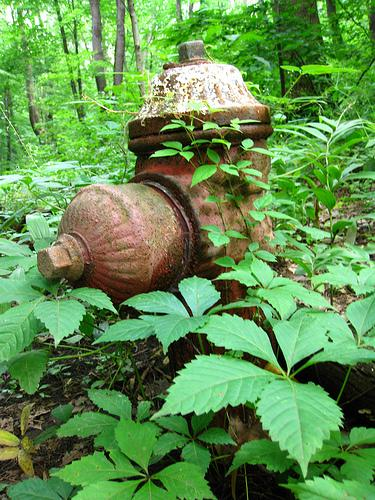What specific object is attached to the fire hydrant? A bolt on the hydrant's cap and a dark grey square on top. Mention the location of the fire hydrant. The fire hydrant is located in the woods. What is the condition of the fire hydrant in the image? The fire hydrant is in a decrepit and worn condition, with chipping white paint and rust. Explain the interaction between the fire hydrant and its surroundings. The fire hydrant is partially hidden and being encroached upon by the surrounding plants and weeds. Identify the primary object in the image and its color. An old fire hydrant is the primary object and it is red and white in color. How many valves are visible on the fire hydrant in the image? One valve is visible on the fire hydrant. Describe the state of the plants around the fire hydrant. The plants are almost covering the hydrant and beginning to hide it. Assess the sentiment evoked by the image, taking into account the fire hydrant's condition and surroundings. The sentiment evoked is a sense of neglect and abandonment, as the old and worn fire hydrant is being overtaken by nature in the woods. What features make the fire hydrant unique in this image? The fire hydrant's old and worn appearance, white chipping paint, rust, and green moss make it unique. Enumerate the vegetation elements surrounding the fire hydrant. Plants, trees, dead leaves, weeds, and moss are surrounding the fire hydrant. Is there a purple flower next to the fire hydrant? There is no mention of a purple flower or any specific color of flower in the given image information. The objects mentioned are mainly related to the fire hydrant, trees, and plants but without any specific color attribute for flowers. What attributes can be noticed on the fire hydrant in the woods? Rusted, mossy, chipping paint, one valve, bolt on the cap How are the plants and fire hydrant interacting in this image? Plants are growing around and almost covering the hydrant. What type of vegetation is present near the fire hydrant? Plants, trees, grass, and weeds. Can you find a cat near the fire hydrant? There is no mention of a cat or any animals in the given image information. The objects mentioned in the image are mostly related to the fire hydrant, trees, and plants. What is the overall atmosphere of the image? Is it positive or negative? Negative, due to the old and decrepit state of the hydrant. Can you find a tall building behind the fire hydrant? There is no mention of a tall building or any buildings in the given image information. The scene in the image is described as a fire hydrant in the woods or forest, with no mention of any urban elements like buildings. How many total valves are found on the fire hydrant? One valve. Is there a person standing next to the fire hydrant? There is no mention of a person or any human figure in the given image information. The objects mentioned in the image are all inanimate objects such as the fire hydrant, plants, and trees. Identify the segments covered by plants in the image. X:30 Y:108 Width:339 Height:339 Identify any unusual elements in the image. Fire hydrant in the woods surrounded by plants. Describe any noticeable conditions on the fire hydrant. Old, worn, chipping white paint, rusted, green moss. Is there a blue fire hydrant in the image? There is no mention of a blue fire hydrant in the given image information. All mentioned fire hydrants are either old, red and white, or worn, but not blue. Describe the position of the large brown tree trunk in the image. X:270 Y:1 Width:82 Height:82 Provide a general description of the fire hydrant's surroundings. Trees, plants, grass, ground with dead leaves. Assess the clarity and composition of the image. Average clarity, composed with fire hydrant in focus. List three objects found in the image. Old fire hydrant, dead leaves, large brown tree trunk. Locate the fire hydrant described as "decrepit old fire hydrant". X:38 Y:31 Width:249 Height:249 What are the locations of the two instances of "part of a root" in the image? 1. X:229 Y:433 Width:2 Height:2 What is the condition of the ground around the fire hydrant? Dead leaves, yellow green leaves, and weeds. What pattern is on the fire hydrant in the image? Red and white. Find any text present in the image. No text present in the image. Can you see a car parked near the fire hydrant? There is no mention of a car or any vehicles in the given image information. The scene described in the image mainly consists of a fire hydrant in the woods, surrounded by plants and trees. Are there any trees in the image? Yes. 